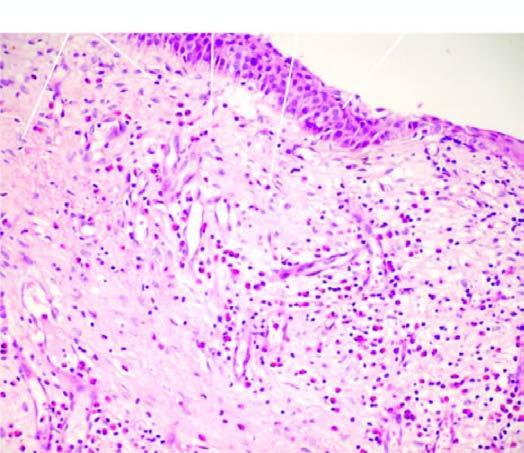what is covered partly by respiratory and partly by squamous metaplastic epithelium?
Answer the question using a single word or phrase. Overlying mucosa 